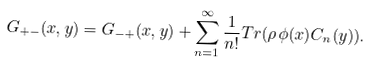<formula> <loc_0><loc_0><loc_500><loc_500>G _ { + - } ( x , y ) = G _ { - + } ( x , y ) + \sum _ { n = 1 } ^ { \infty } \frac { 1 } { n ! } T r ( \rho \, \phi ( x ) C _ { n } ( y ) ) .</formula> 